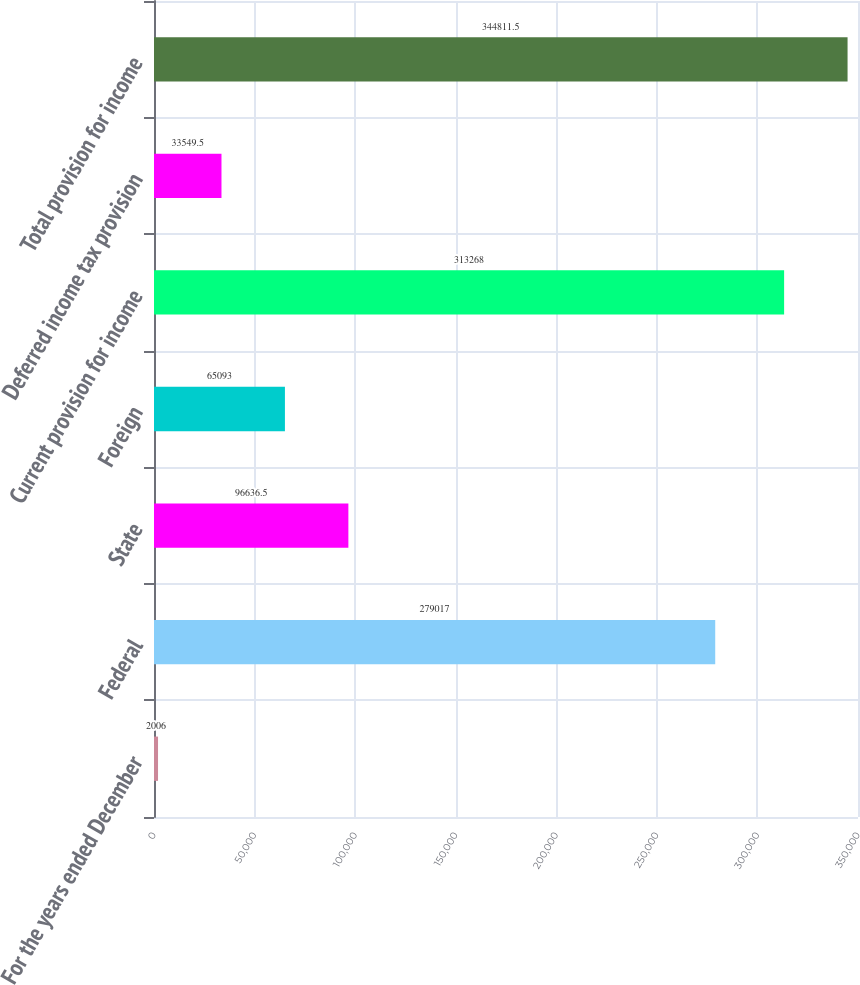Convert chart. <chart><loc_0><loc_0><loc_500><loc_500><bar_chart><fcel>For the years ended December<fcel>Federal<fcel>State<fcel>Foreign<fcel>Current provision for income<fcel>Deferred income tax provision<fcel>Total provision for income<nl><fcel>2006<fcel>279017<fcel>96636.5<fcel>65093<fcel>313268<fcel>33549.5<fcel>344812<nl></chart> 